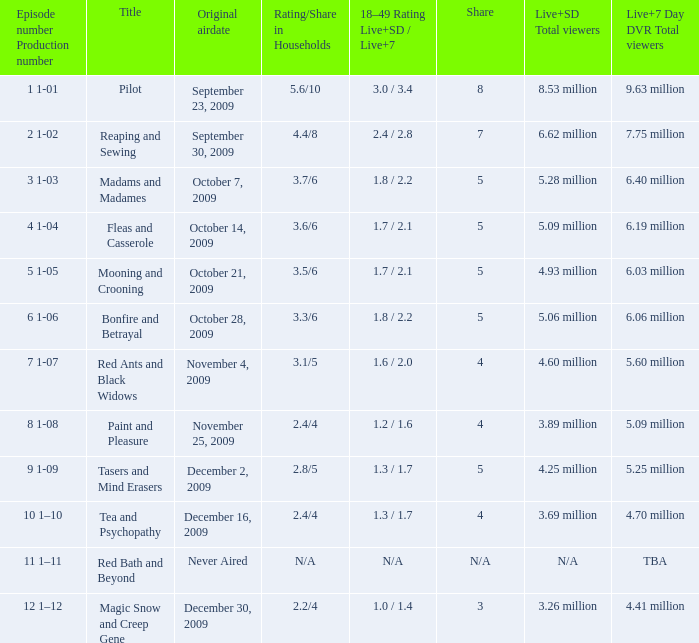When was the episode with October 14, 2009. 